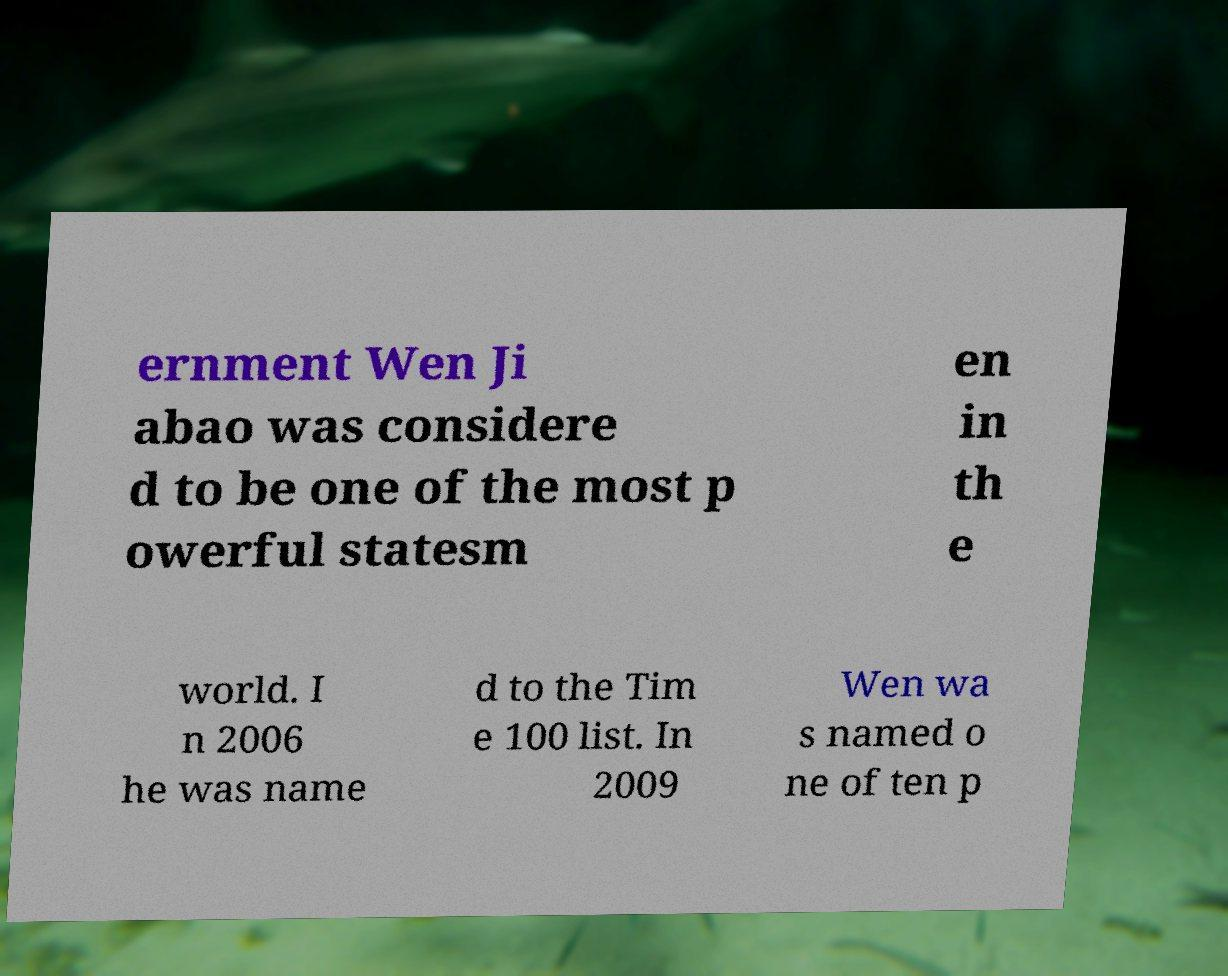There's text embedded in this image that I need extracted. Can you transcribe it verbatim? ernment Wen Ji abao was considere d to be one of the most p owerful statesm en in th e world. I n 2006 he was name d to the Tim e 100 list. In 2009 Wen wa s named o ne of ten p 